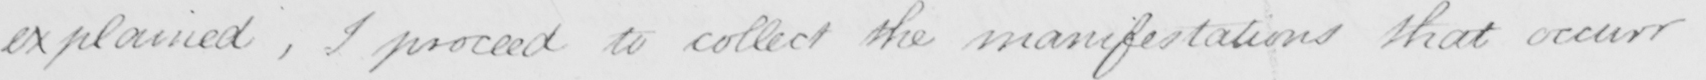What does this handwritten line say? explained , I proceed to collect the manifestations that occurr 